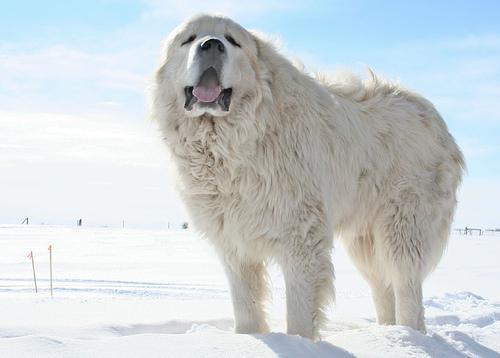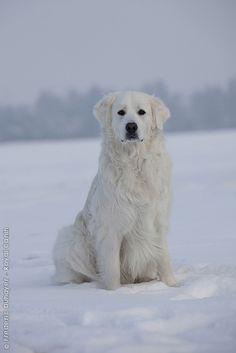The first image is the image on the left, the second image is the image on the right. For the images displayed, is the sentence "A dogs lies down in the snow in the image on the left." factually correct? Answer yes or no. No. 